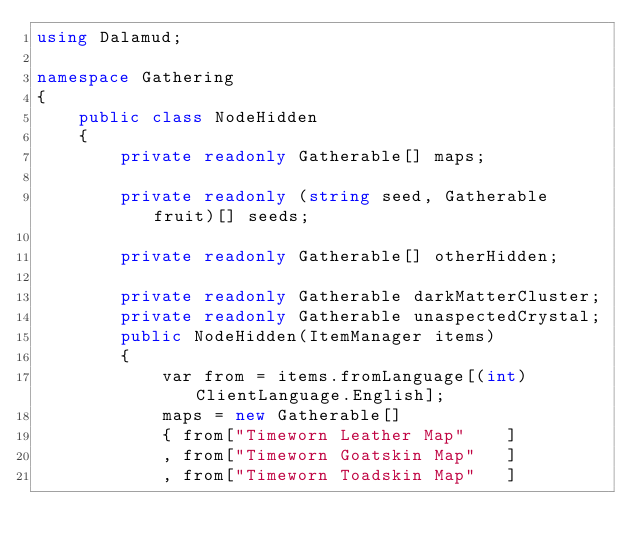Convert code to text. <code><loc_0><loc_0><loc_500><loc_500><_C#_>using Dalamud;

namespace Gathering
{
    public class NodeHidden
    {
        private readonly Gatherable[] maps;

        private readonly (string seed, Gatherable fruit)[] seeds;

        private readonly Gatherable[] otherHidden;

        private readonly Gatherable darkMatterCluster;
        private readonly Gatherable unaspectedCrystal;
        public NodeHidden(ItemManager items)
        {
            var from = items.fromLanguage[(int)ClientLanguage.English];
            maps = new Gatherable[]
            { from["Timeworn Leather Map"    ]
            , from["Timeworn Goatskin Map"   ]
            , from["Timeworn Toadskin Map"   ]</code> 